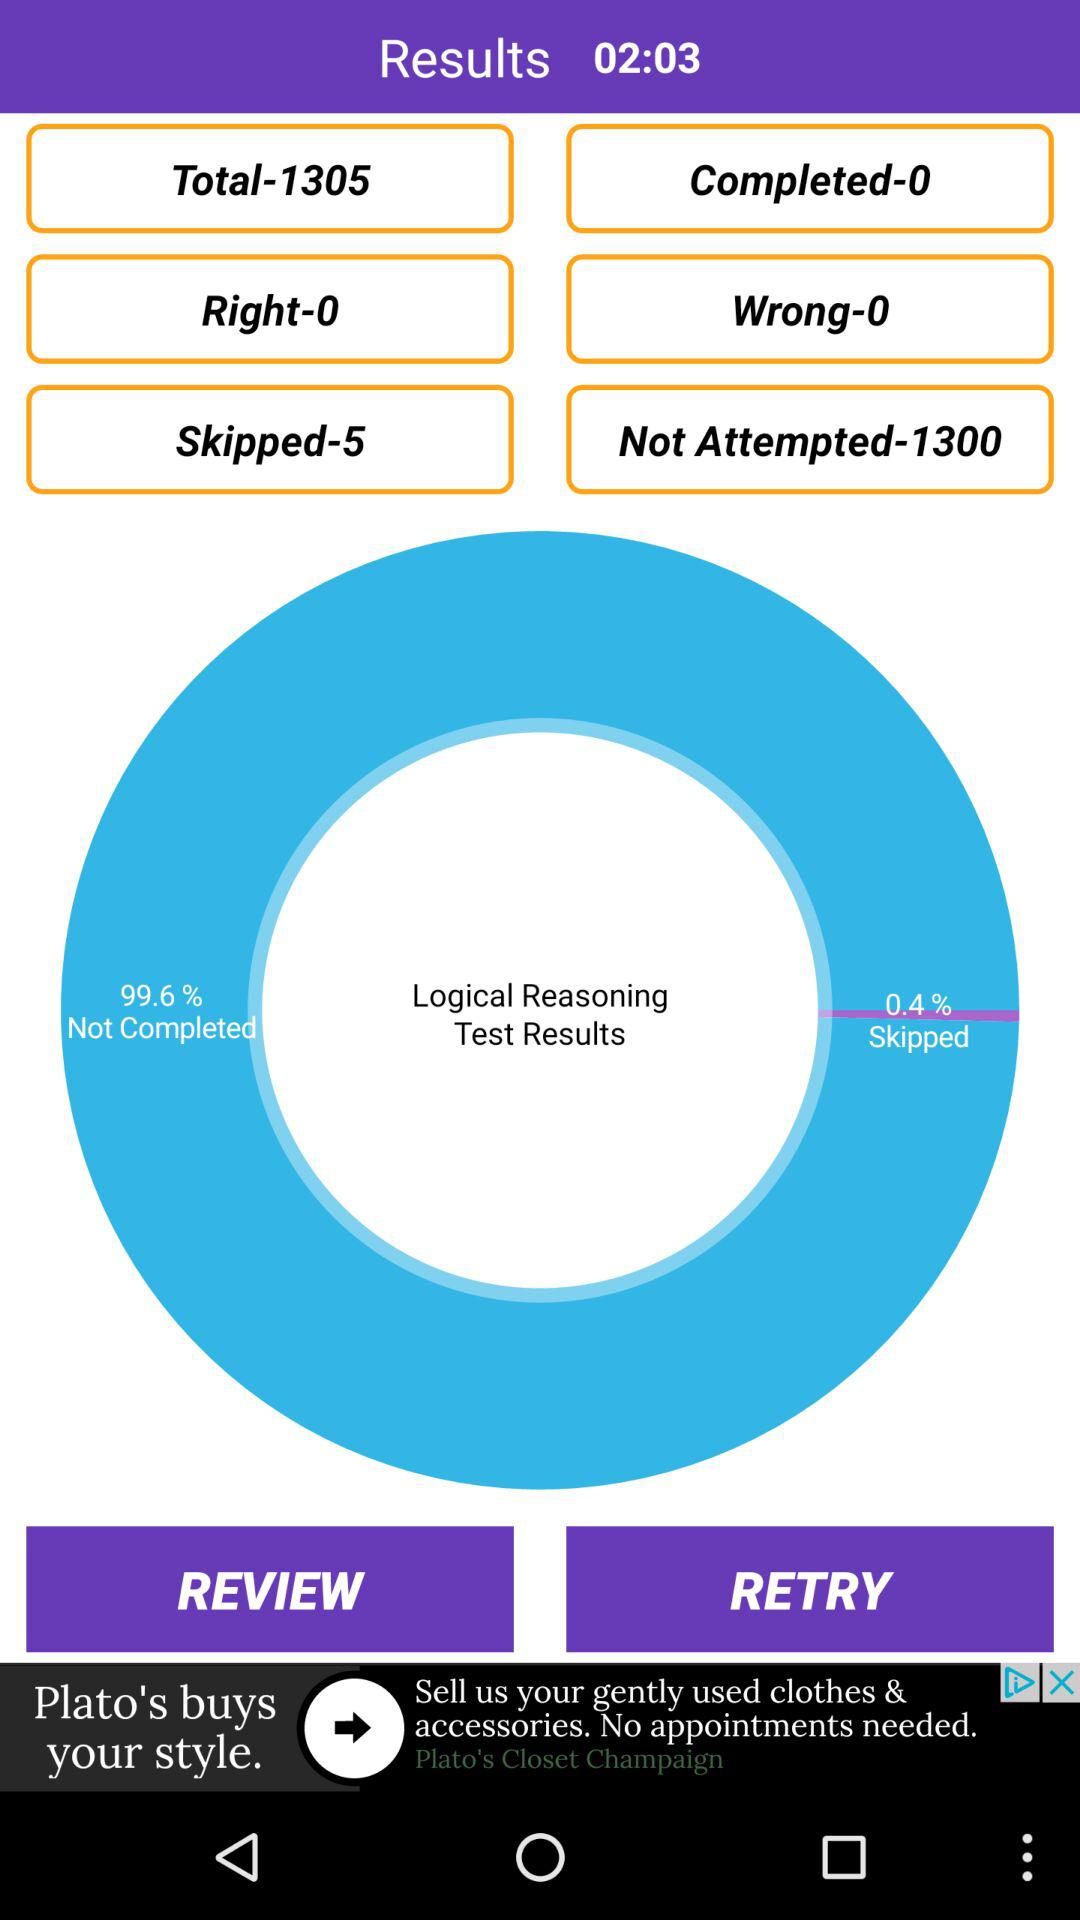How many questions were not attempted?
Answer the question using a single word or phrase. 1300 